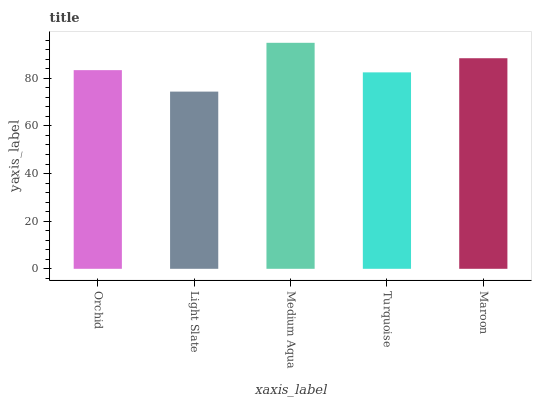Is Light Slate the minimum?
Answer yes or no. Yes. Is Medium Aqua the maximum?
Answer yes or no. Yes. Is Medium Aqua the minimum?
Answer yes or no. No. Is Light Slate the maximum?
Answer yes or no. No. Is Medium Aqua greater than Light Slate?
Answer yes or no. Yes. Is Light Slate less than Medium Aqua?
Answer yes or no. Yes. Is Light Slate greater than Medium Aqua?
Answer yes or no. No. Is Medium Aqua less than Light Slate?
Answer yes or no. No. Is Orchid the high median?
Answer yes or no. Yes. Is Orchid the low median?
Answer yes or no. Yes. Is Medium Aqua the high median?
Answer yes or no. No. Is Light Slate the low median?
Answer yes or no. No. 